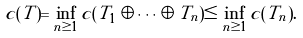Convert formula to latex. <formula><loc_0><loc_0><loc_500><loc_500>c ( T ) = \inf _ { n \geq 1 } c ( T _ { 1 } \oplus \cdots \oplus T _ { n } ) \leq \inf _ { n \geq 1 } c ( T _ { n } ) .</formula> 